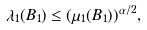<formula> <loc_0><loc_0><loc_500><loc_500>\lambda _ { 1 } ( B _ { 1 } ) \leq ( \mu _ { 1 } ( B _ { 1 } ) ) ^ { \alpha / 2 } ,</formula> 